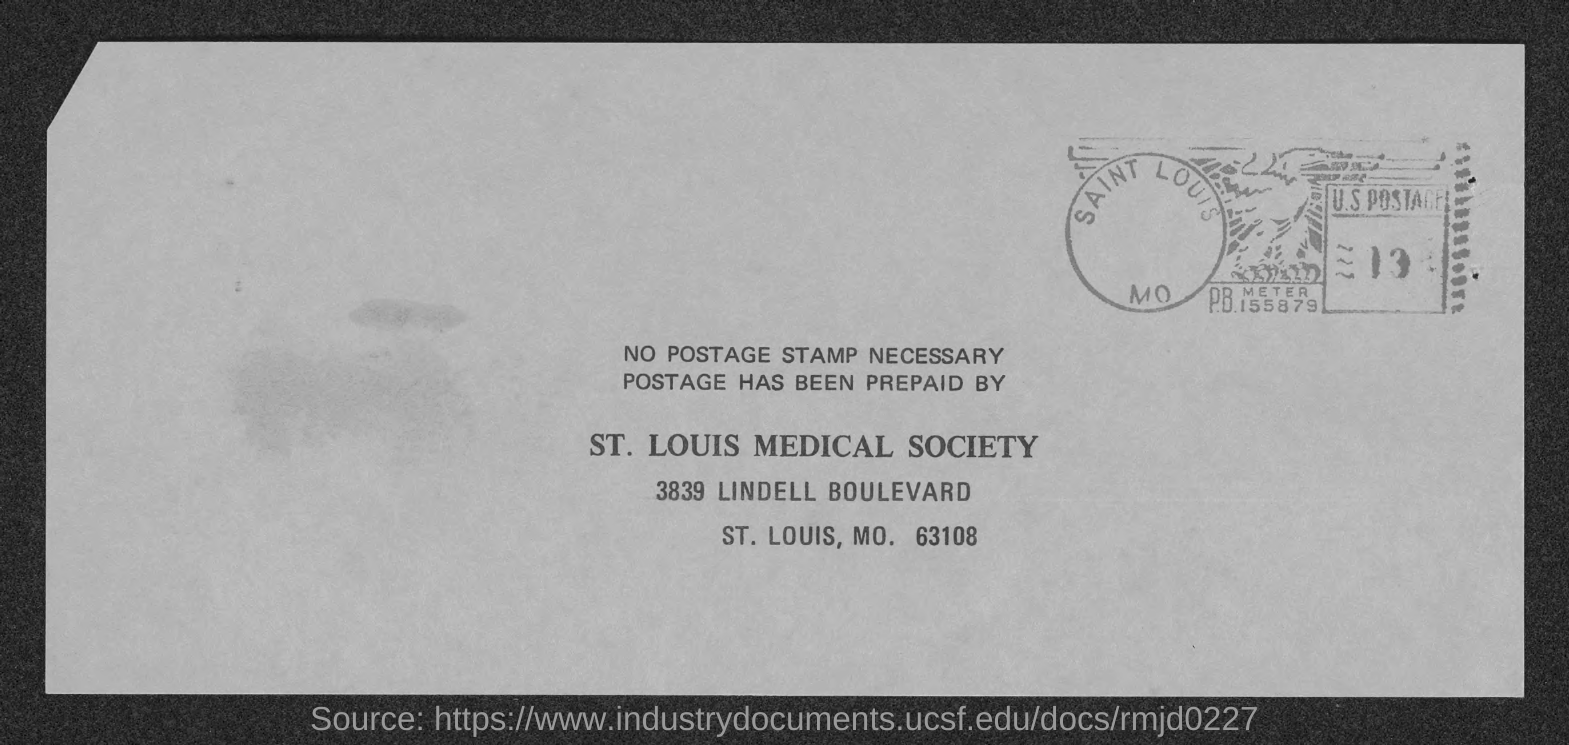What is the street address of st. louis medical society ?
Your response must be concise. 3839 Lindell Boulevard. 